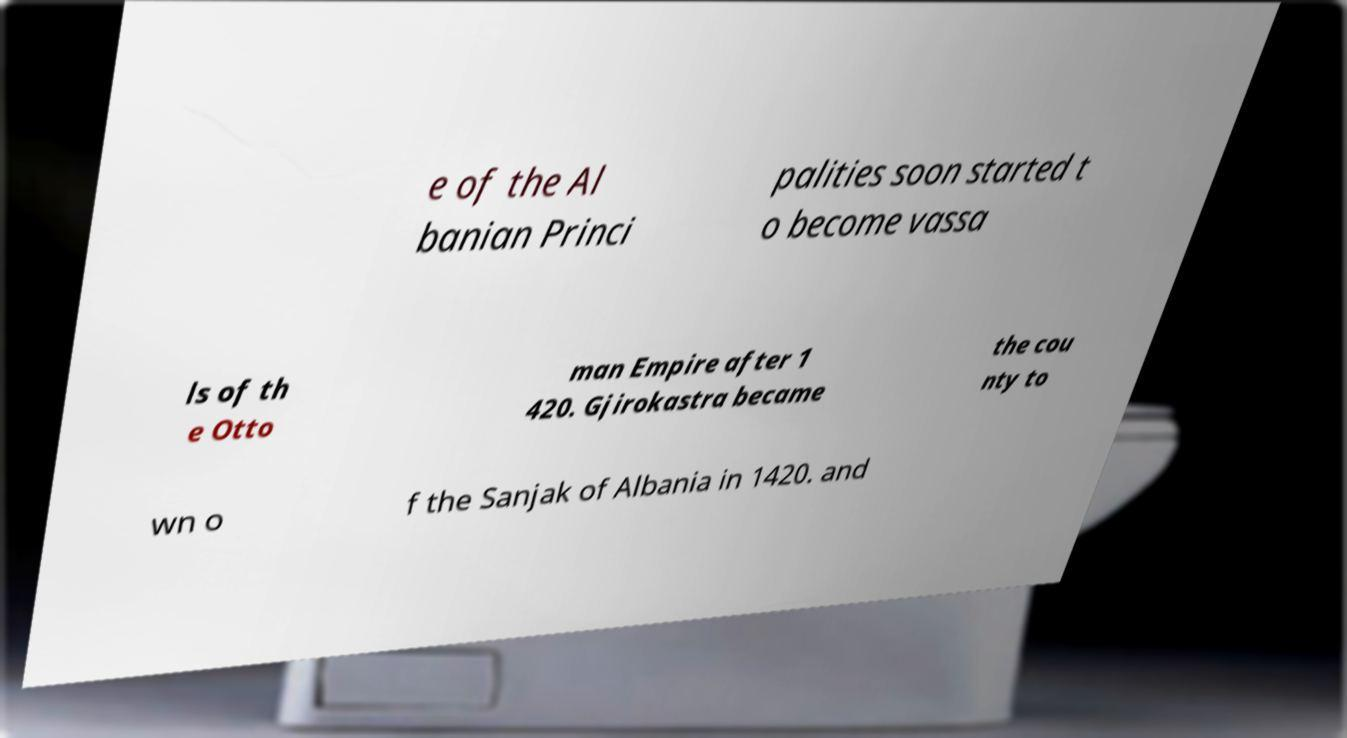Can you read and provide the text displayed in the image?This photo seems to have some interesting text. Can you extract and type it out for me? e of the Al banian Princi palities soon started t o become vassa ls of th e Otto man Empire after 1 420. Gjirokastra became the cou nty to wn o f the Sanjak of Albania in 1420. and 